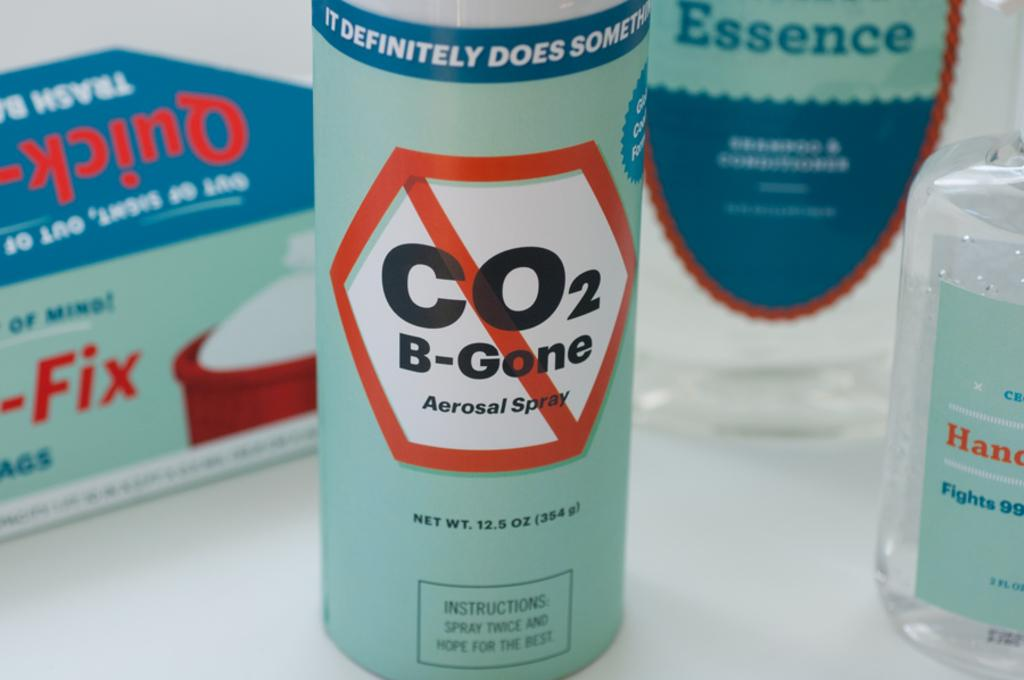<image>
Provide a brief description of the given image. a can of co2 b-gone aerosal spray on a white base 